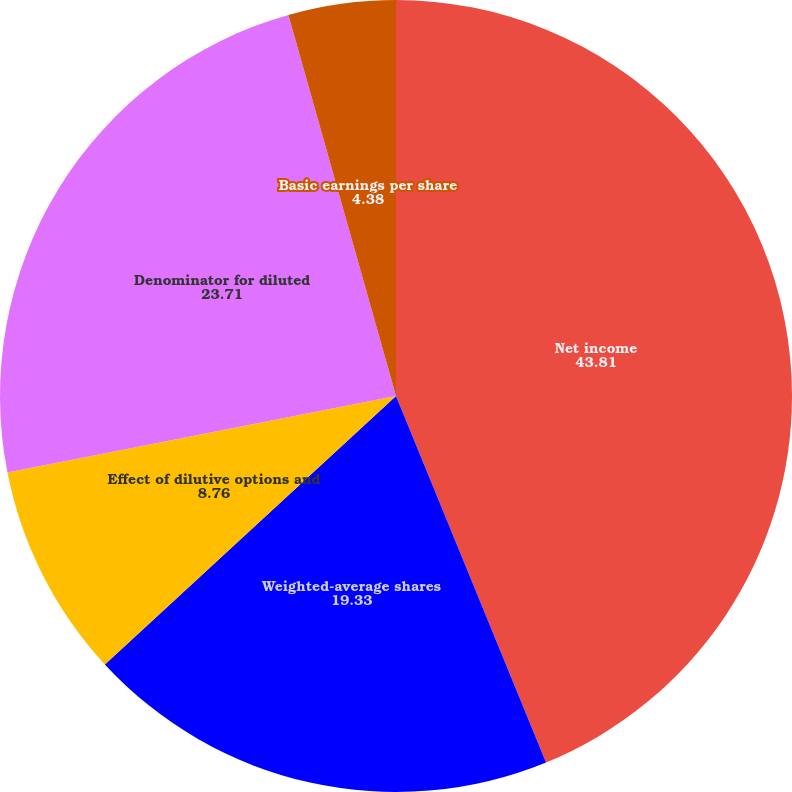<chart> <loc_0><loc_0><loc_500><loc_500><pie_chart><fcel>Net income<fcel>Weighted-average shares<fcel>Effect of dilutive options and<fcel>Denominator for diluted<fcel>Basic earnings per share<fcel>Diluted earnings per share<nl><fcel>43.81%<fcel>19.33%<fcel>8.76%<fcel>23.71%<fcel>4.38%<fcel>0.0%<nl></chart> 